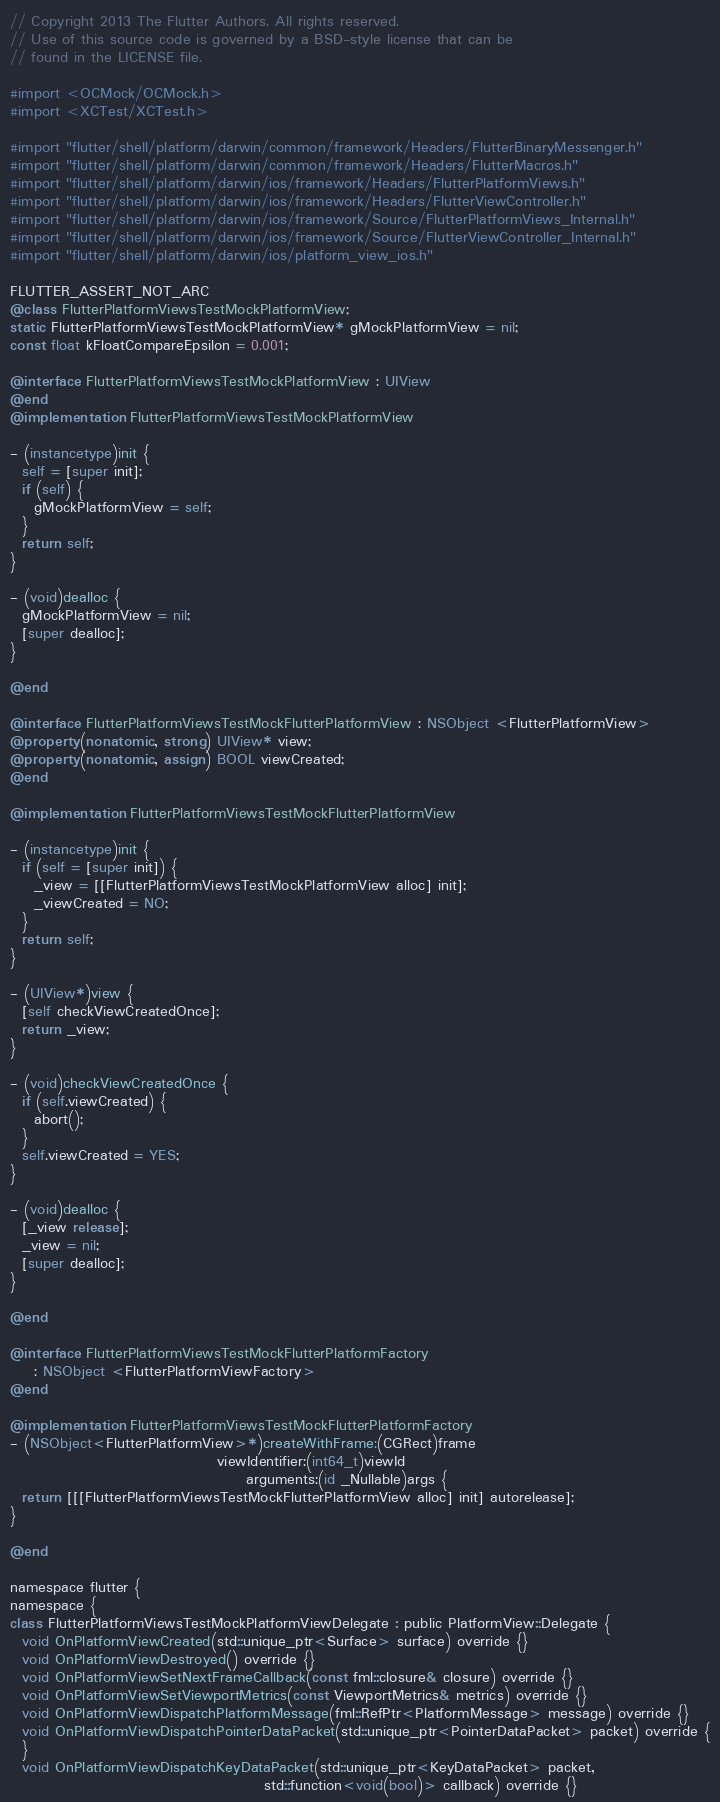<code> <loc_0><loc_0><loc_500><loc_500><_ObjectiveC_>// Copyright 2013 The Flutter Authors. All rights reserved.
// Use of this source code is governed by a BSD-style license that can be
// found in the LICENSE file.

#import <OCMock/OCMock.h>
#import <XCTest/XCTest.h>

#import "flutter/shell/platform/darwin/common/framework/Headers/FlutterBinaryMessenger.h"
#import "flutter/shell/platform/darwin/common/framework/Headers/FlutterMacros.h"
#import "flutter/shell/platform/darwin/ios/framework/Headers/FlutterPlatformViews.h"
#import "flutter/shell/platform/darwin/ios/framework/Headers/FlutterViewController.h"
#import "flutter/shell/platform/darwin/ios/framework/Source/FlutterPlatformViews_Internal.h"
#import "flutter/shell/platform/darwin/ios/framework/Source/FlutterViewController_Internal.h"
#import "flutter/shell/platform/darwin/ios/platform_view_ios.h"

FLUTTER_ASSERT_NOT_ARC
@class FlutterPlatformViewsTestMockPlatformView;
static FlutterPlatformViewsTestMockPlatformView* gMockPlatformView = nil;
const float kFloatCompareEpsilon = 0.001;

@interface FlutterPlatformViewsTestMockPlatformView : UIView
@end
@implementation FlutterPlatformViewsTestMockPlatformView

- (instancetype)init {
  self = [super init];
  if (self) {
    gMockPlatformView = self;
  }
  return self;
}

- (void)dealloc {
  gMockPlatformView = nil;
  [super dealloc];
}

@end

@interface FlutterPlatformViewsTestMockFlutterPlatformView : NSObject <FlutterPlatformView>
@property(nonatomic, strong) UIView* view;
@property(nonatomic, assign) BOOL viewCreated;
@end

@implementation FlutterPlatformViewsTestMockFlutterPlatformView

- (instancetype)init {
  if (self = [super init]) {
    _view = [[FlutterPlatformViewsTestMockPlatformView alloc] init];
    _viewCreated = NO;
  }
  return self;
}

- (UIView*)view {
  [self checkViewCreatedOnce];
  return _view;
}

- (void)checkViewCreatedOnce {
  if (self.viewCreated) {
    abort();
  }
  self.viewCreated = YES;
}

- (void)dealloc {
  [_view release];
  _view = nil;
  [super dealloc];
}

@end

@interface FlutterPlatformViewsTestMockFlutterPlatformFactory
    : NSObject <FlutterPlatformViewFactory>
@end

@implementation FlutterPlatformViewsTestMockFlutterPlatformFactory
- (NSObject<FlutterPlatformView>*)createWithFrame:(CGRect)frame
                                   viewIdentifier:(int64_t)viewId
                                        arguments:(id _Nullable)args {
  return [[[FlutterPlatformViewsTestMockFlutterPlatformView alloc] init] autorelease];
}

@end

namespace flutter {
namespace {
class FlutterPlatformViewsTestMockPlatformViewDelegate : public PlatformView::Delegate {
  void OnPlatformViewCreated(std::unique_ptr<Surface> surface) override {}
  void OnPlatformViewDestroyed() override {}
  void OnPlatformViewSetNextFrameCallback(const fml::closure& closure) override {}
  void OnPlatformViewSetViewportMetrics(const ViewportMetrics& metrics) override {}
  void OnPlatformViewDispatchPlatformMessage(fml::RefPtr<PlatformMessage> message) override {}
  void OnPlatformViewDispatchPointerDataPacket(std::unique_ptr<PointerDataPacket> packet) override {
  }
  void OnPlatformViewDispatchKeyDataPacket(std::unique_ptr<KeyDataPacket> packet,
                                           std::function<void(bool)> callback) override {}</code> 